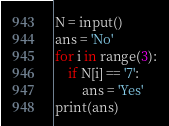Convert code to text. <code><loc_0><loc_0><loc_500><loc_500><_Python_>N = input()
ans = 'No'
for i in range(3):
    if N[i] == '7':
        ans = 'Yes'
print(ans)</code> 